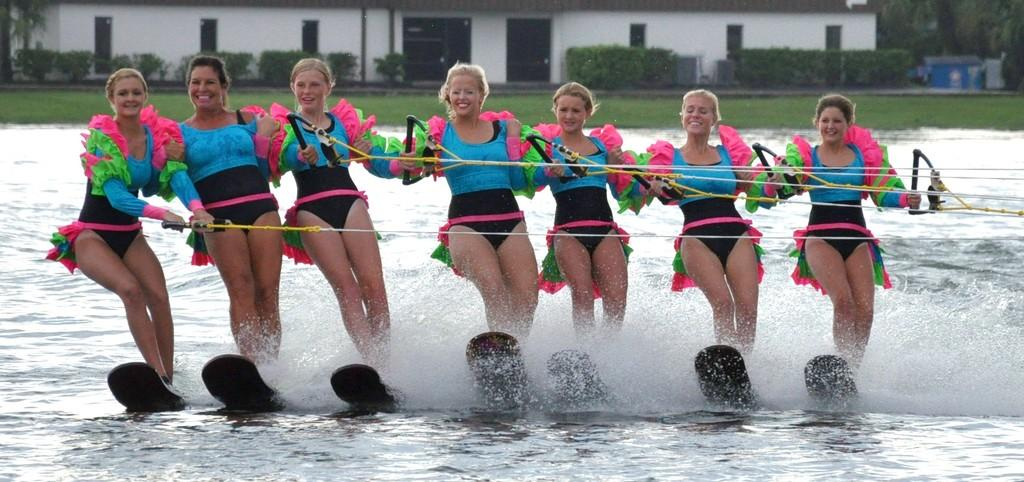What is happening in the image involving the group of women? The women are surfing in the image. What are the women holding while surfing? The women are holding ropes in the image. What can be seen in the background of the image? There is a building, doors, and windows in the backdrop of the image. How does the selection process work for the tramp in the image? There is no tramp present in the image, so it is not possible to discuss a selection process. 